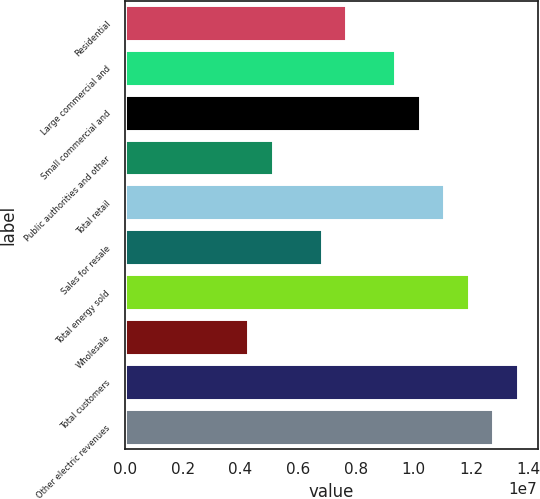<chart> <loc_0><loc_0><loc_500><loc_500><bar_chart><fcel>Residential<fcel>Large commercial and<fcel>Small commercial and<fcel>Public authorities and other<fcel>Total retail<fcel>Sales for resale<fcel>Total energy sold<fcel>Wholesale<fcel>Total customers<fcel>Other electric revenues<nl><fcel>7.66557e+06<fcel>9.36903e+06<fcel>1.02208e+07<fcel>5.11038e+06<fcel>1.10725e+07<fcel>6.81384e+06<fcel>1.19242e+07<fcel>4.25865e+06<fcel>1.36277e+07<fcel>1.27759e+07<nl></chart> 